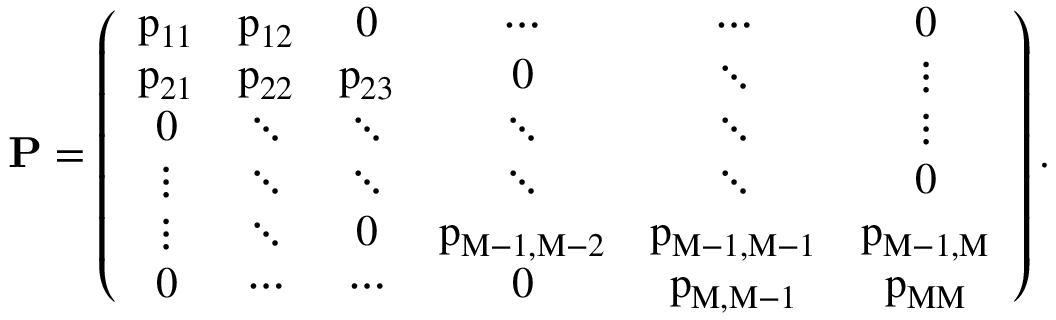<formula> <loc_0><loc_0><loc_500><loc_500>{ { P } = \left ( { \begin{array} { c c c c c c } { p _ { 1 1 } } & { p _ { 1 2 } } & { 0 } & { \cdots } & { \cdots } & { 0 } \\ { p _ { 2 1 } } & { p _ { 2 2 } } & { p _ { 2 3 } } & { 0 } & { \ddots } & { \vdots } \\ { 0 } & { \ddots } & { \ddots } & { \ddots } & { \ddots } & { \vdots } \\ { \vdots } & { \ddots } & { \ddots } & { \ddots } & { \ddots } & { 0 } \\ { \vdots } & { \ddots } & { 0 } & { p _ { M - 1 , M - 2 } } & { p _ { M - 1 , M - 1 } } & { p _ { M - 1 , M } } \\ { 0 } & { \cdots } & { \cdots } & { 0 } & { p _ { M , M - 1 } } & { p _ { M M } } \end{array} } \right ) . }</formula> 